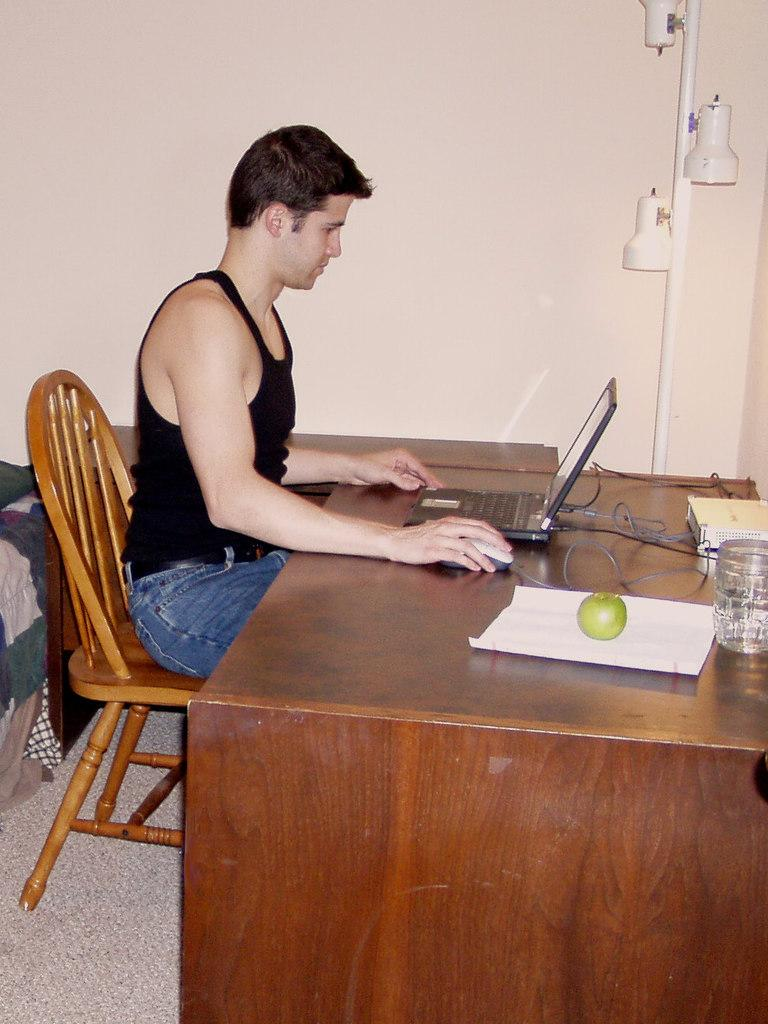What is the person in the image doing? The person is sitting on a chair and operating a laptop. Where is the laptop located in the image? The laptop is on a table. What is depicted on the paper in the image? There is a fruit depicted on the paper. What type of collar is the person wearing in the image? There is no collar visible in the image, as the person is wearing a shirt or blouse. Is there a fan present in the image? No, there is no fan visible in the image. 